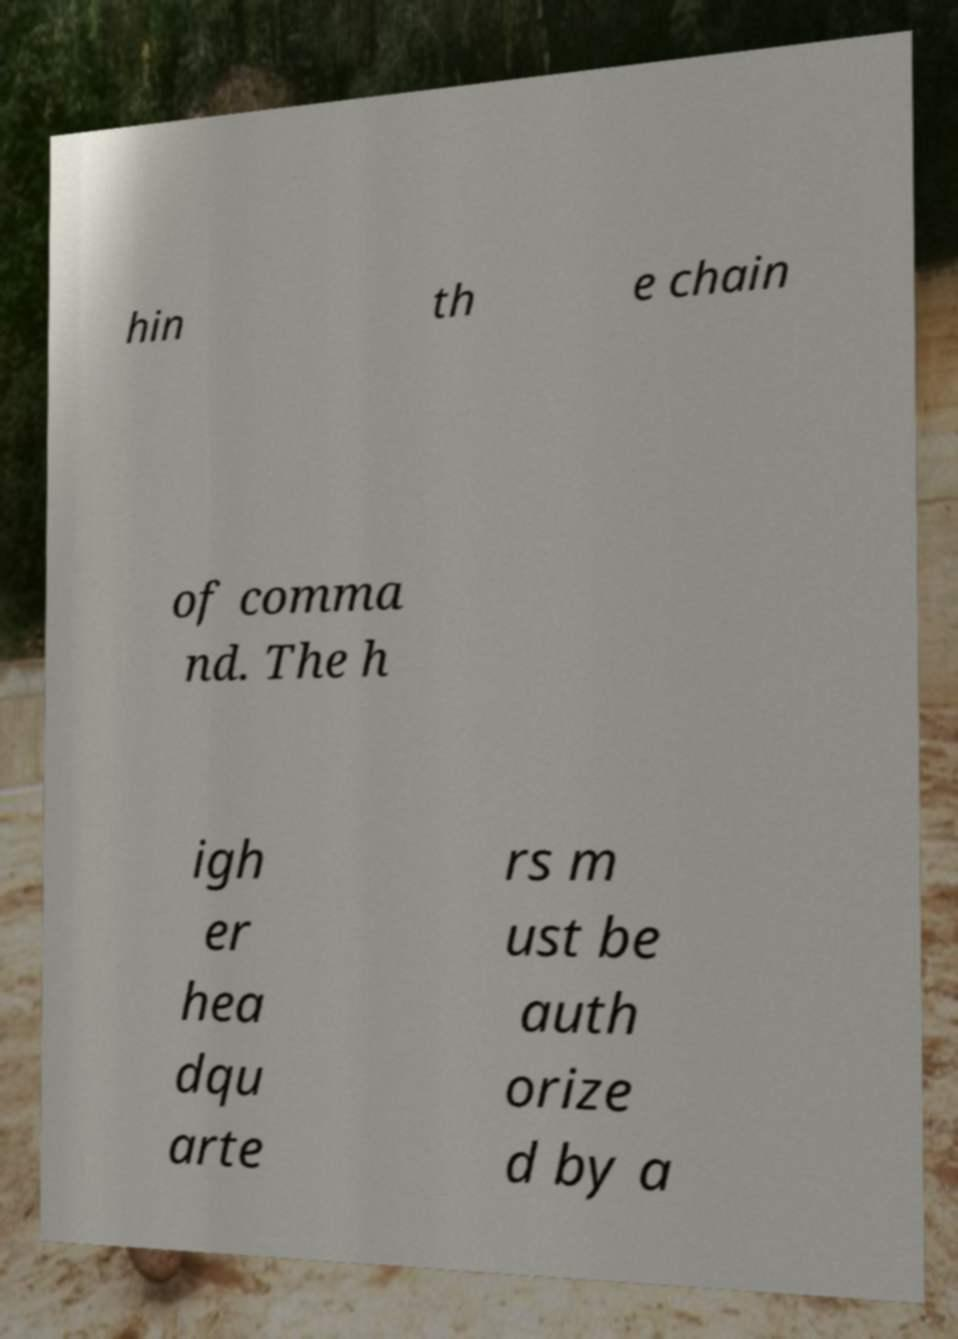I need the written content from this picture converted into text. Can you do that? hin th e chain of comma nd. The h igh er hea dqu arte rs m ust be auth orize d by a 